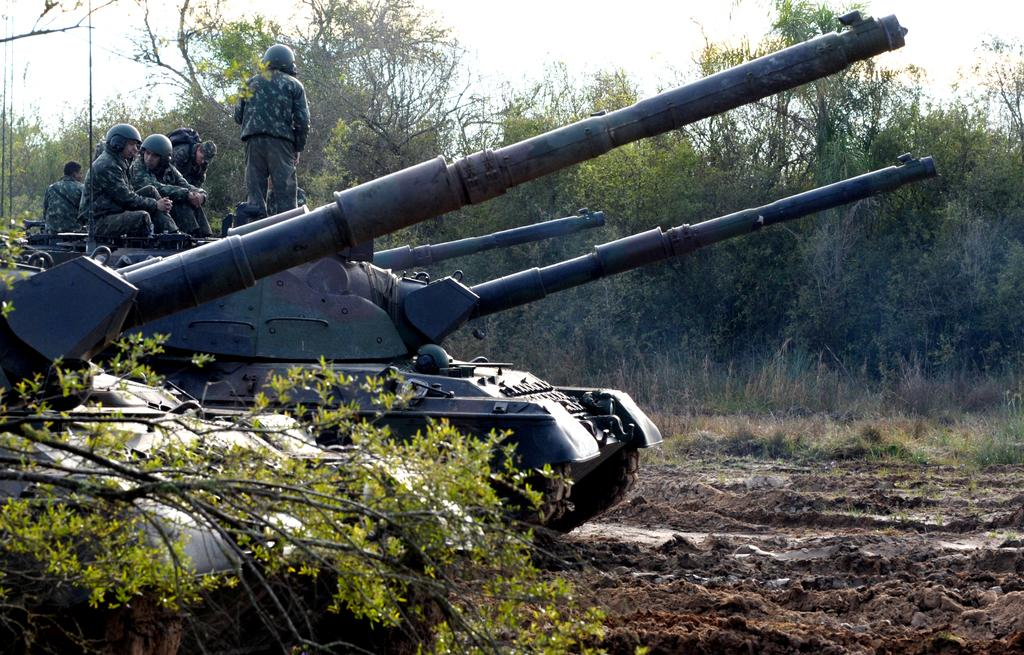What type of vegetation can be seen in the image? There are trees and grass in the image. What else is present in the image besides vegetation? There are tanks and people in the image. What are the people wearing in the image? The people are wearing uniforms, and some of them are wearing helmets. What type of grain is being harvested by the people in the image? There is no grain present in the image; it features trees, grass, tanks, and people wearing uniforms and helmets. How are the people in the image helping each other? The image does not show any specific actions of the people helping each other; it only shows them wearing uniforms and helmets. 